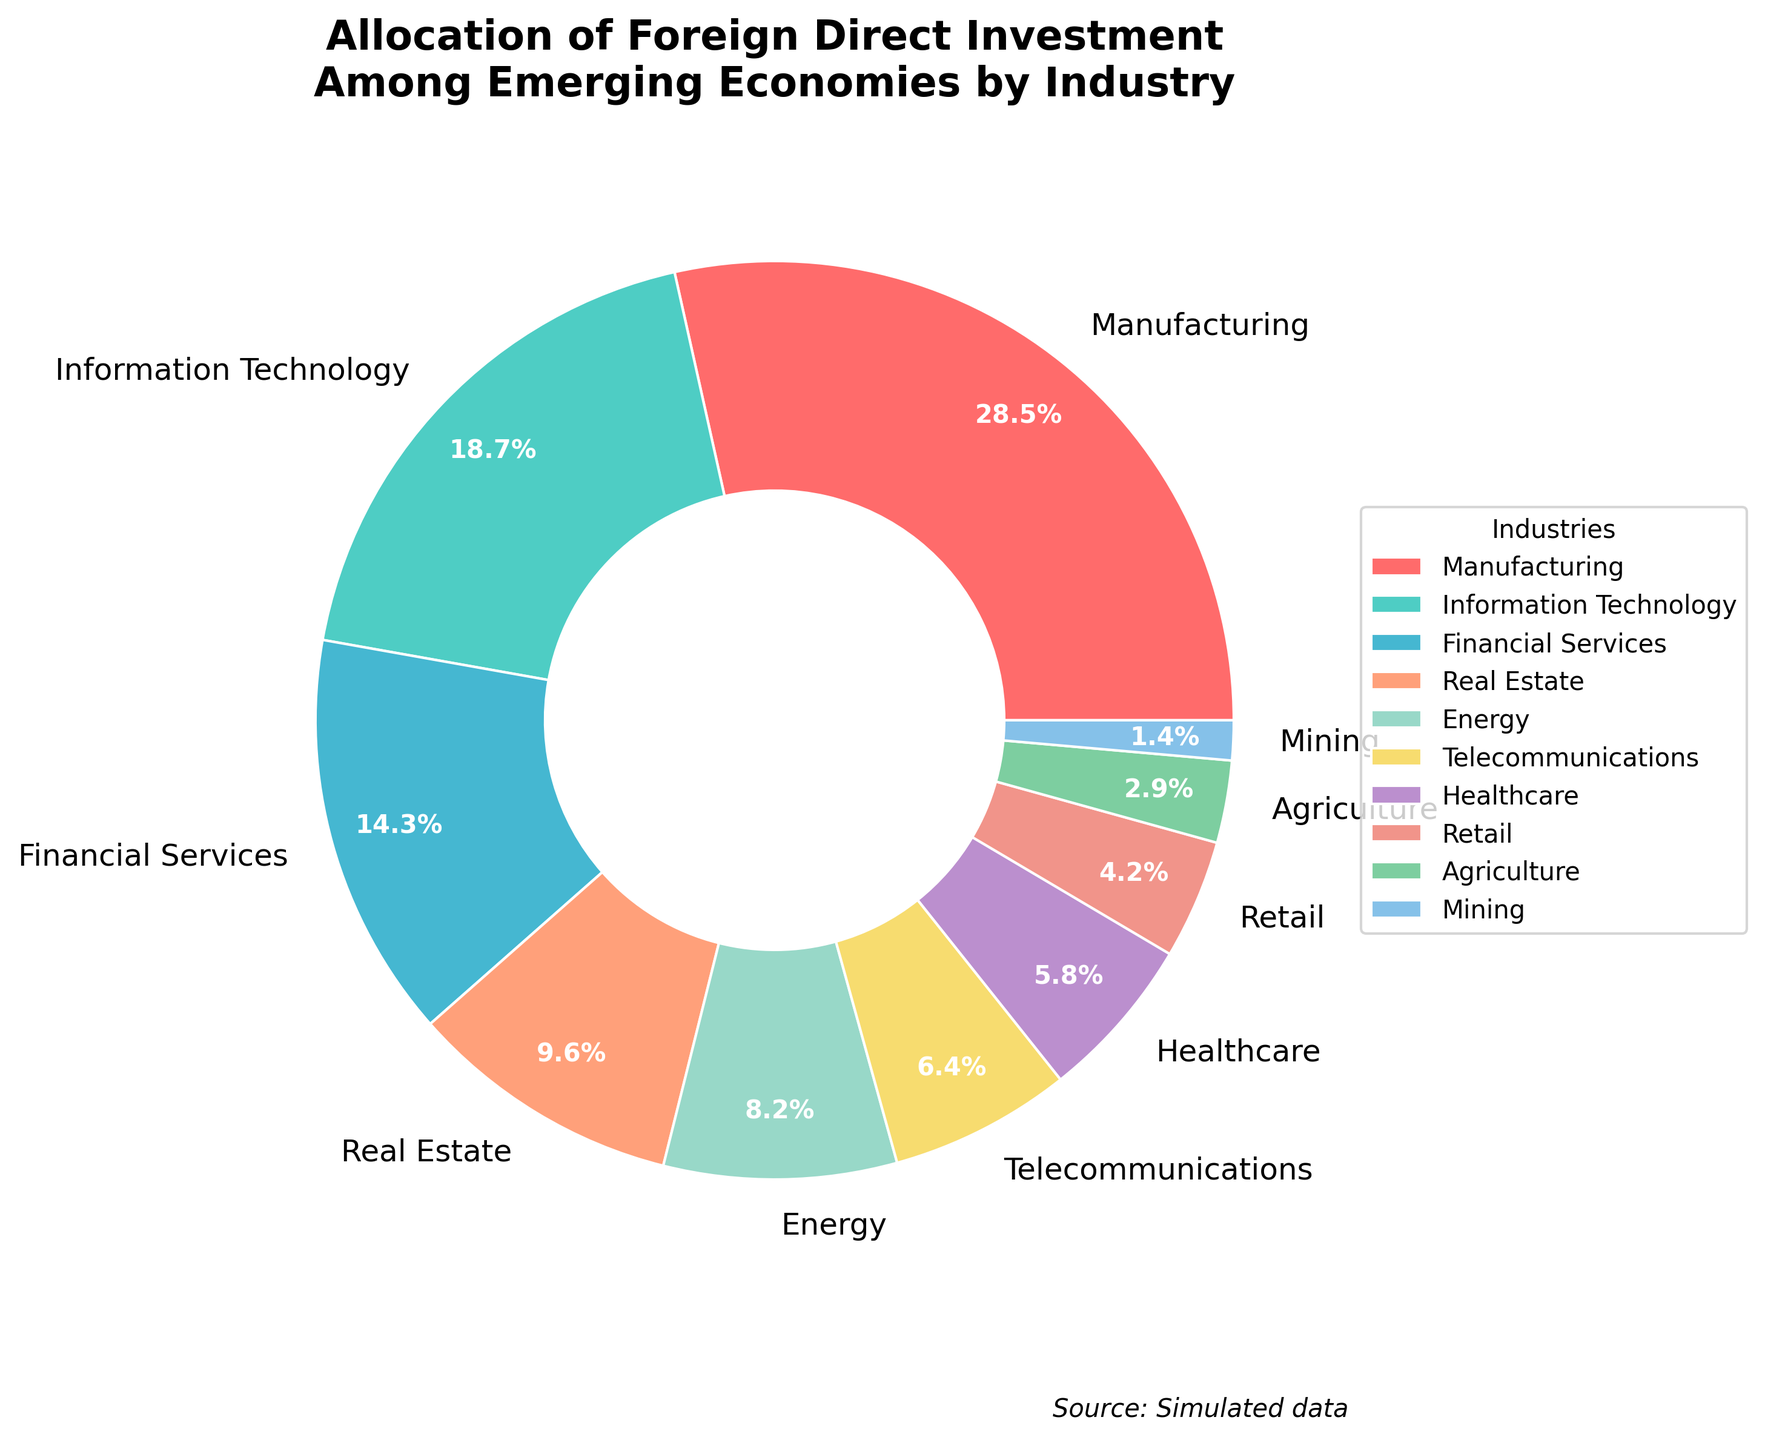What is the combined percentage of Manufacturing, Information Technology, and Financial Services? Add the percentages of Manufacturing (28.5), Information Technology (18.7), and Financial Services (14.3). The sum is 28.5 + 18.7 + 14.3 = 61.5%
Answer: 61.5% Which industry receives the least amount of foreign direct investment? From the chart, Mining has the lowest percentage at 1.4%
Answer: Mining Is the percentage of investment in Healthcare higher than that in Telecommunications? From the chart, Healthcare has 5.8% and Telecommunications has 6.4%. Hence, Healthcare has a lower percentage than Telecommunications
Answer: No What is the ratio of investment in Real Estate to that in Agriculture? Real Estate has 9.6% and Agriculture has 2.9%. The ratio is calculated as 9.6 / 2.9 ≈ 3.31
Answer: 3.31 Which industry has the highest allocation of investment and what is its percentage? Manufacturing has the highest allocation at 28.5%
Answer: Manufacturing, 28.5% Compare the percentage of investment in Energy and Telecommunications. What is the difference between them? Energy has 8.2% and Telecommunications has 6.4%. The difference is 8.2% - 6.4% = 1.8%
Answer: 1.8% What color represents the Financial Services industry? The chart shows Financial Services in a purple shade
Answer: Purple (BB8FCE) How much more investment does Manufacturing receive compared to the combined total of Retail and Mining? Manufacturing has 28.5%. Retail has 4.2% and Mining has 1.4%, so their sum is 4.2% + 1.4% = 5.6%. The difference is 28.5% - 5.6% = 22.9%
Answer: 22.9% Order the top three industries in terms of foreign direct investment allocation. From highest to lowest: Manufacturing (28.5%), Information Technology (18.7%), and Financial Services (14.3%)
Answer: Manufacturing, Information Technology, Financial Services Does the Real Estate industry receive more investment than the combined total of Healthcare and Agriculture? Real Estate has 9.6%. Healthcare and Agriculture combined have 5.8% + 2.9% = 8.7%. Since 9.6% is more than 8.7%, Real Estate receives more investment
Answer: Yes 